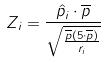Convert formula to latex. <formula><loc_0><loc_0><loc_500><loc_500>Z _ { i } = \frac { \hat { p } _ { i } \cdot \overline { p } } { \sqrt { \frac { \overline { p } ( 5 \cdot \overline { p } ) } { r _ { i } } } }</formula> 